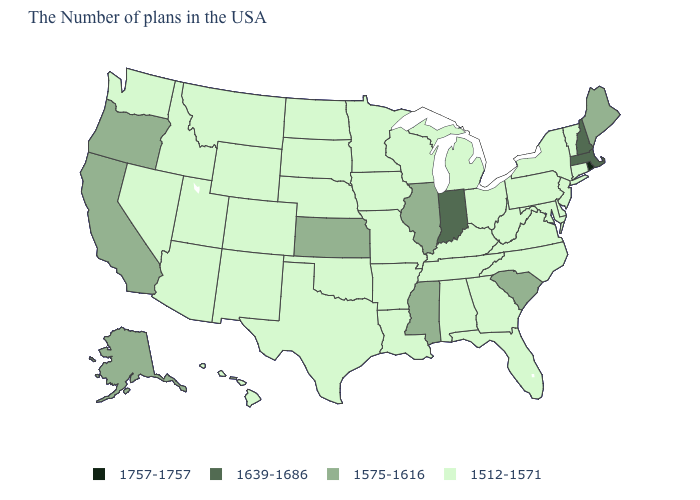What is the value of Idaho?
Concise answer only. 1512-1571. Name the states that have a value in the range 1575-1616?
Give a very brief answer. Maine, South Carolina, Illinois, Mississippi, Kansas, California, Oregon, Alaska. Is the legend a continuous bar?
Be succinct. No. Among the states that border Nevada , which have the highest value?
Short answer required. California, Oregon. Does the map have missing data?
Quick response, please. No. What is the highest value in the USA?
Give a very brief answer. 1757-1757. Among the states that border Minnesota , which have the lowest value?
Give a very brief answer. Wisconsin, Iowa, South Dakota, North Dakota. Does the first symbol in the legend represent the smallest category?
Keep it brief. No. What is the value of Florida?
Short answer required. 1512-1571. Is the legend a continuous bar?
Be succinct. No. What is the value of South Dakota?
Answer briefly. 1512-1571. Does Idaho have a lower value than Oregon?
Give a very brief answer. Yes. What is the lowest value in the Northeast?
Keep it brief. 1512-1571. What is the value of Connecticut?
Answer briefly. 1512-1571. 